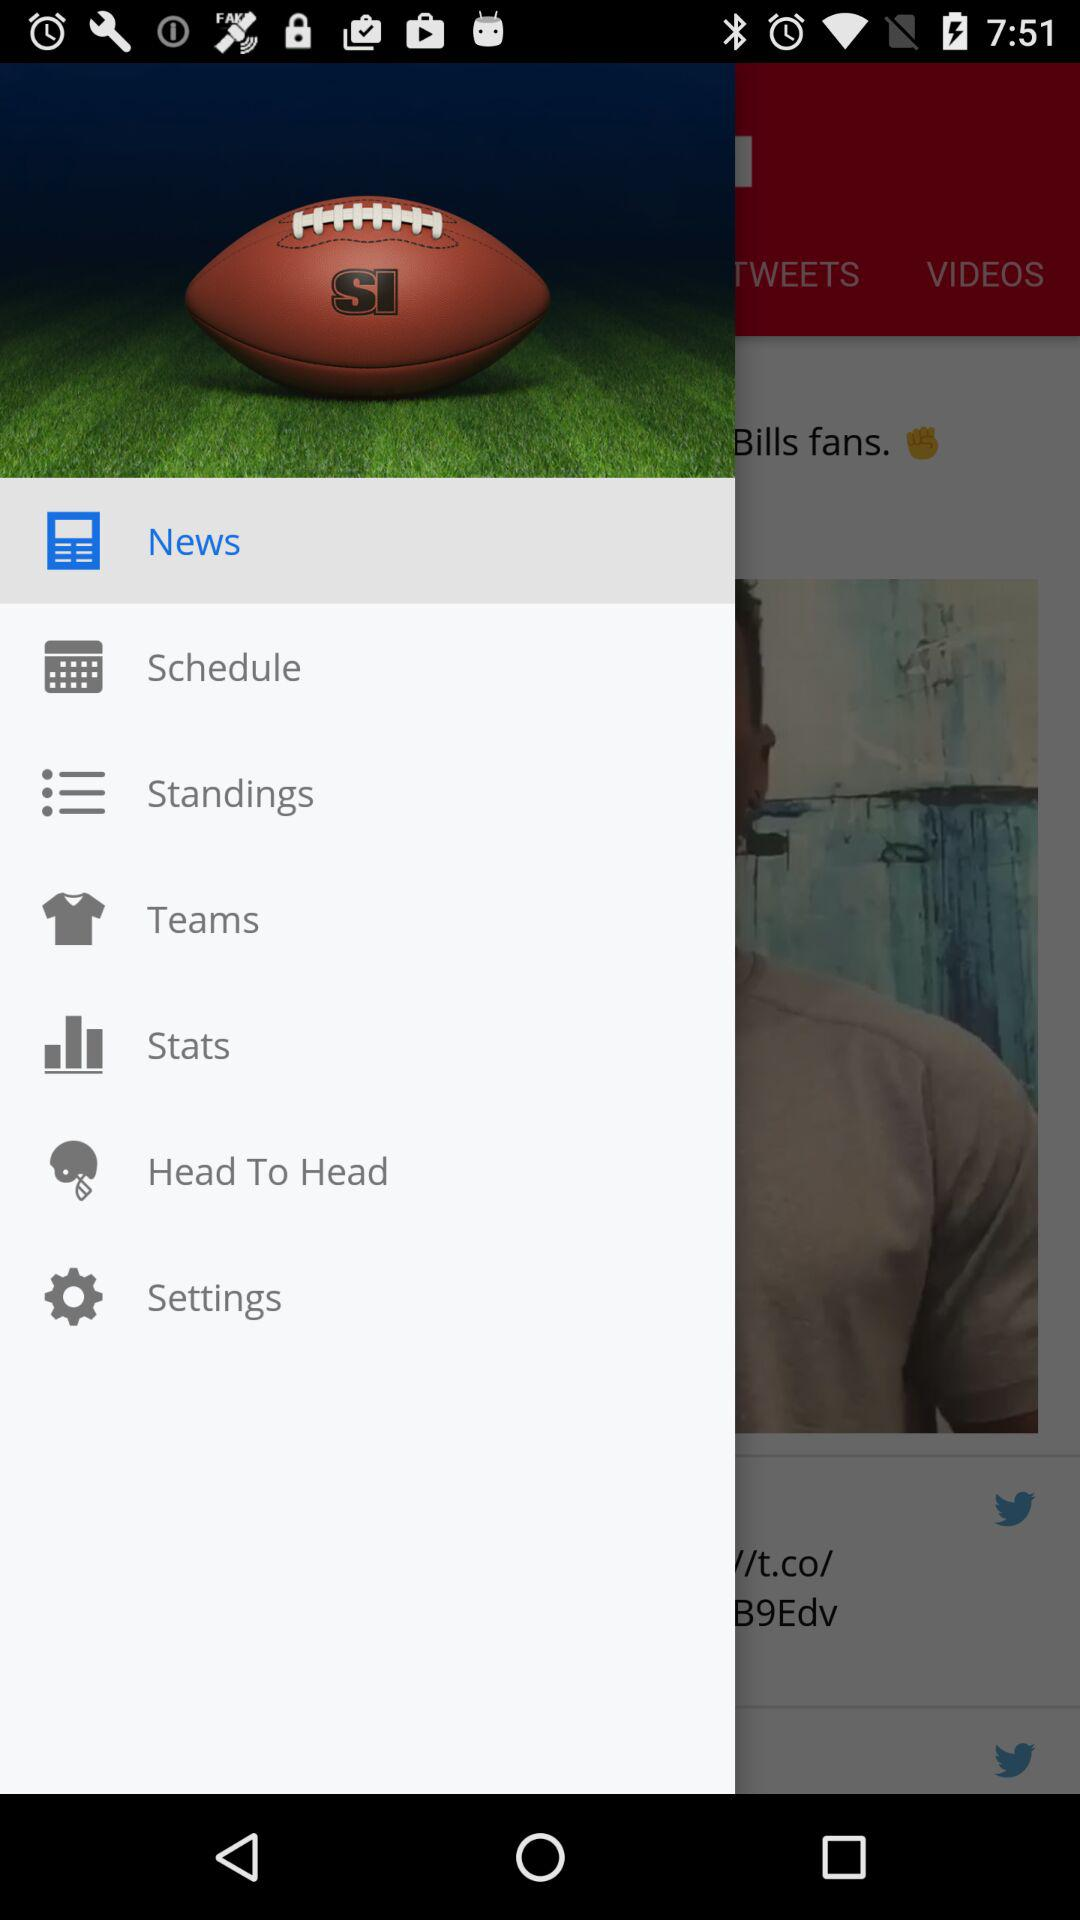What is the selected option? The selected option is "News". 